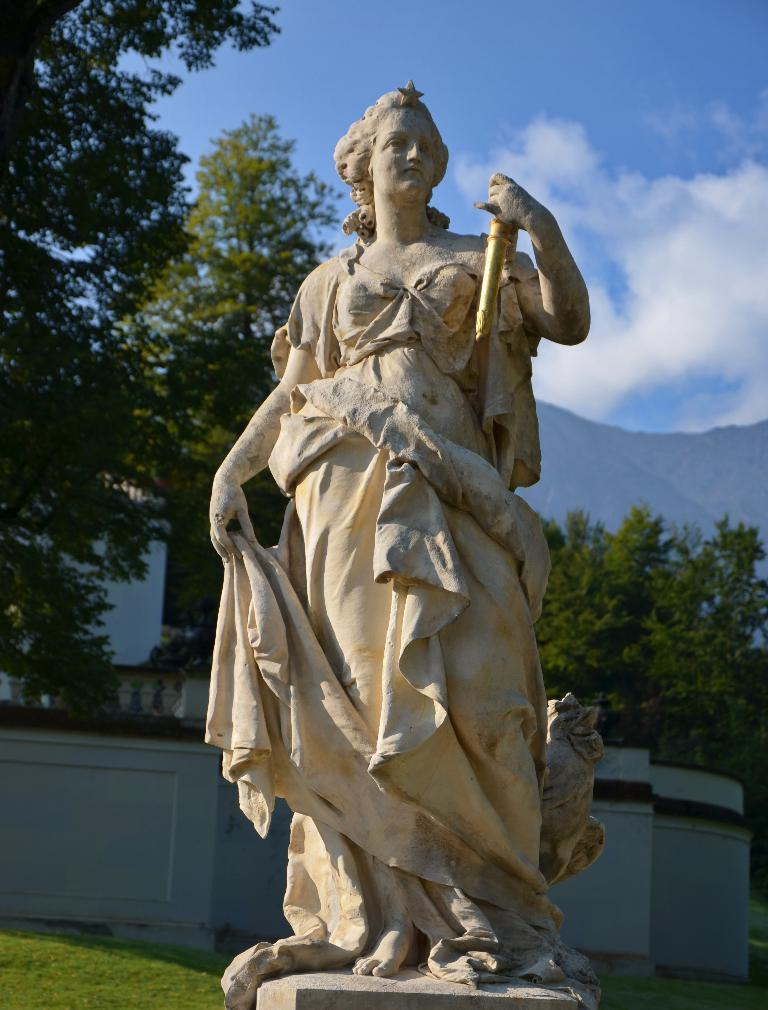What is the main subject in the front of the image? There is a statue in the front of the image. What type of vegetation can be seen on the ground in the center of the image? There is grass on the ground in the center of the image. What can be seen in the background of the image? There is a wall and trees in the background of the image. How would you describe the sky in the background of the image? The sky is cloudy in the background of the image. Is there any snow visible on the ground in the image? No, there is no snow visible on the ground in the image; it is grass that can be seen. 